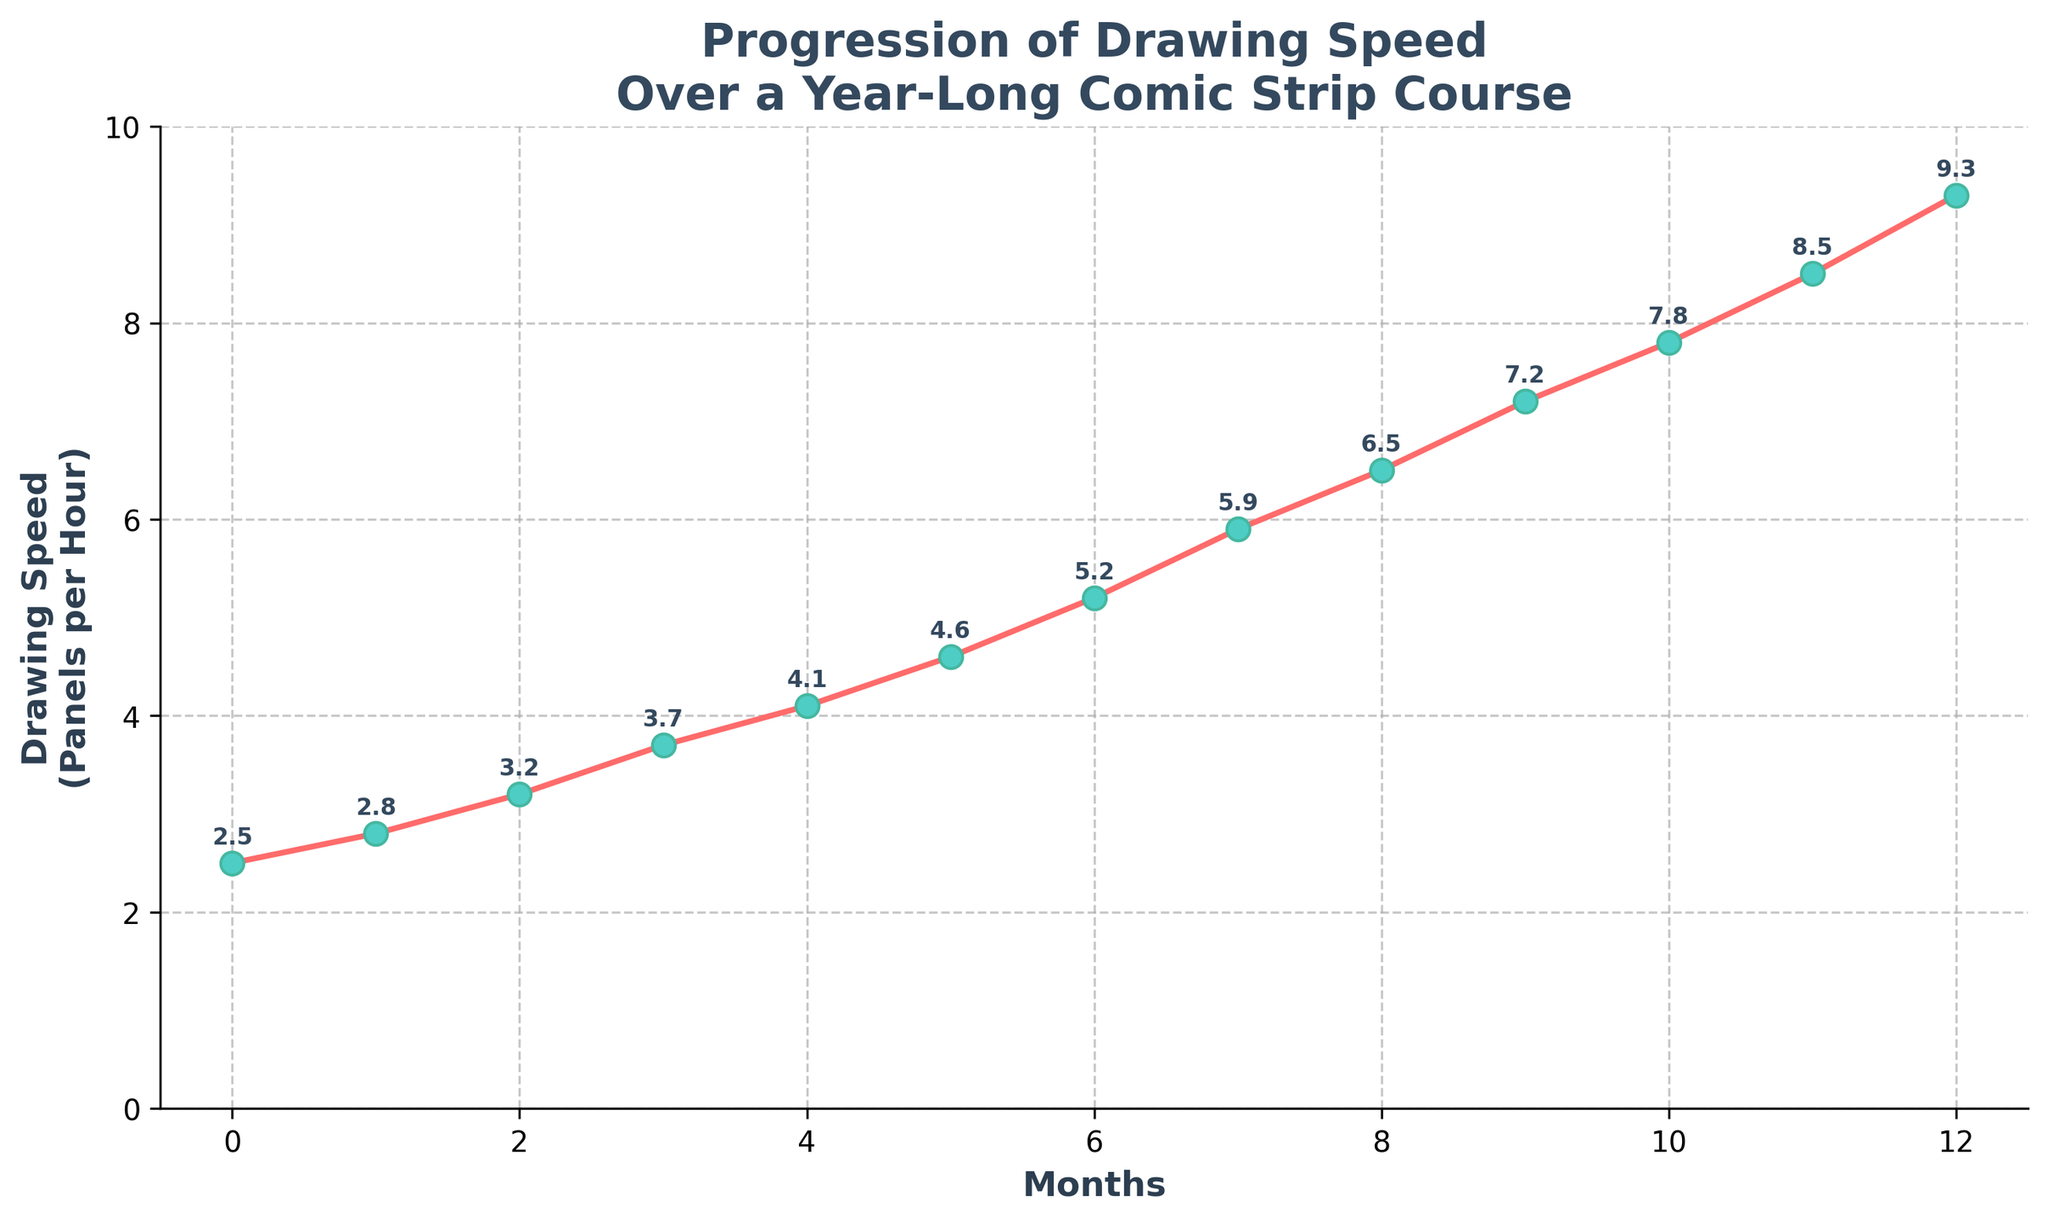What is the drawing speed in the 6th month? Look for the drawing speed corresponding to month 6 on the X-axis. The figure shows it's 5.2 panels per hour.
Answer: 5.2 From month 0 to month 12, what is the total increase in drawing speed? Subtract the drawing speed at month 0 from the drawing speed at month 12. The difference is 9.3 - 2.5.
Answer: 6.8 At which month did the drawing speed exceed 4 panels per hour? Locate the points where the drawing speed is above 4. The first month this happens is month 4.
Answer: 4 What is the average drawing speed recorded in the first six months? Add the drawing speeds from months 0 to 5 and divide by 6. That's (2.5 + 2.8 + 3.2 + 3.7 + 4.1 + 4.6) / 6.
Answer: 3.48 How many months did it take for the drawing speed to reach at least 7 panels per hour? Identify when the drawing speed first reaches or exceeds 7, which is in month 9.
Answer: 9 Compare the difference in drawing speed between month 7 and month 2. Subtract the drawing speed at month 2 from the drawing speed at month 7. The difference is 5.9 - 3.2.
Answer: 2.7 What is the drawing speed trend over the year? Observing the plot, the drawing speed shows a consistent increase each month.
Answer: Increasing Identify the month with the highest increase in drawing speed compared to the previous month. Verify each month's increase and identify the largest increase. Month 11 to 12 (8.5 to 9.3) is 0.8, which is the highest.
Answer: Month 12 How many times does the drawing speed increment exceed 0.5 panels per hour over consecutive months? Check the difference between consecutive months and count the number of times it exceeds 0.5. This occurs from month 6 to 7 (0.7), 7 to 8 (0.6), and 9 to 10 (0.6).
Answer: 3 